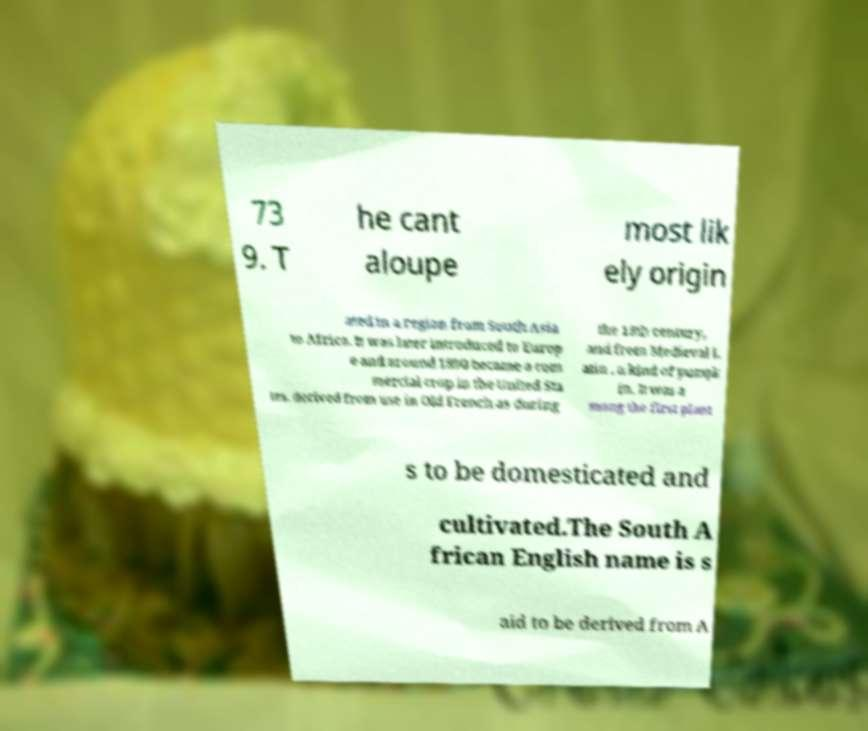Please read and relay the text visible in this image. What does it say? 73 9. T he cant aloupe most lik ely origin ated in a region from South Asia to Africa. It was later introduced to Europ e and around 1890 became a com mercial crop in the United Sta tes. derived from use in Old French as during the 13th century, and from Medieval L atin , a kind of pumpk in. It was a mong the first plant s to be domesticated and cultivated.The South A frican English name is s aid to be derived from A 